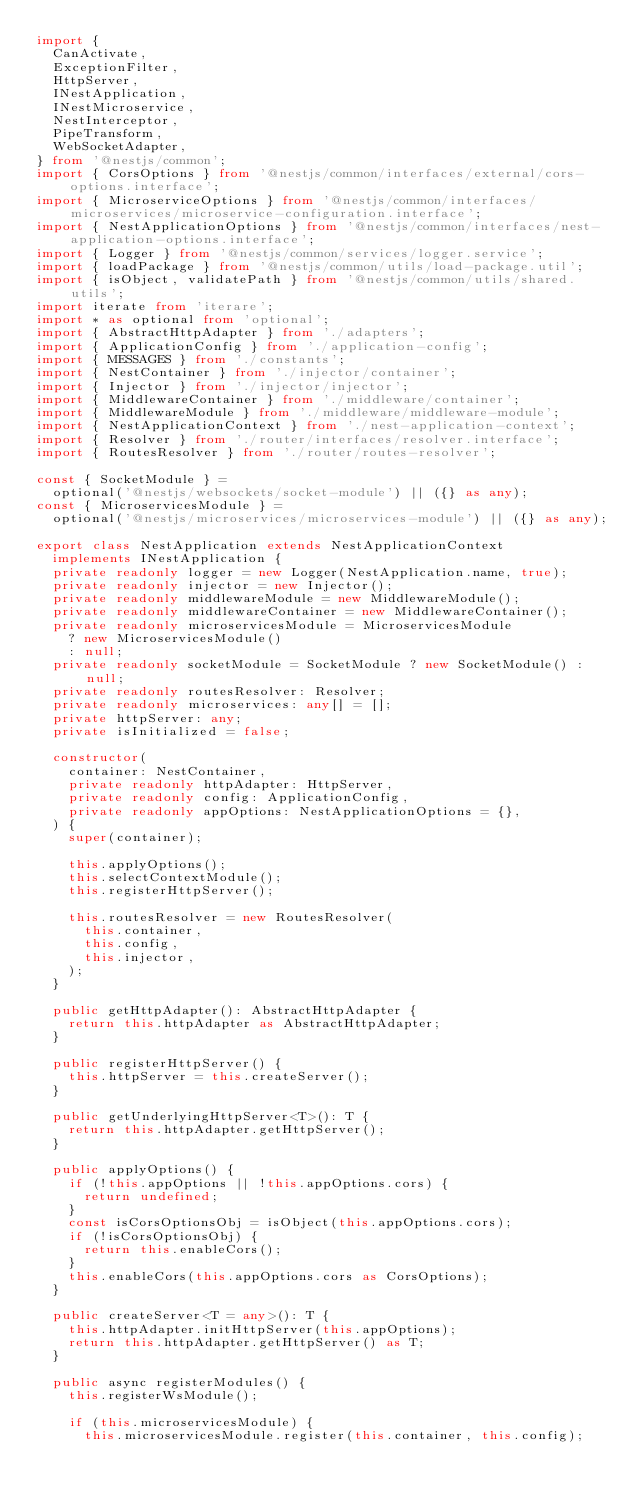Convert code to text. <code><loc_0><loc_0><loc_500><loc_500><_TypeScript_>import {
  CanActivate,
  ExceptionFilter,
  HttpServer,
  INestApplication,
  INestMicroservice,
  NestInterceptor,
  PipeTransform,
  WebSocketAdapter,
} from '@nestjs/common';
import { CorsOptions } from '@nestjs/common/interfaces/external/cors-options.interface';
import { MicroserviceOptions } from '@nestjs/common/interfaces/microservices/microservice-configuration.interface';
import { NestApplicationOptions } from '@nestjs/common/interfaces/nest-application-options.interface';
import { Logger } from '@nestjs/common/services/logger.service';
import { loadPackage } from '@nestjs/common/utils/load-package.util';
import { isObject, validatePath } from '@nestjs/common/utils/shared.utils';
import iterate from 'iterare';
import * as optional from 'optional';
import { AbstractHttpAdapter } from './adapters';
import { ApplicationConfig } from './application-config';
import { MESSAGES } from './constants';
import { NestContainer } from './injector/container';
import { Injector } from './injector/injector';
import { MiddlewareContainer } from './middleware/container';
import { MiddlewareModule } from './middleware/middleware-module';
import { NestApplicationContext } from './nest-application-context';
import { Resolver } from './router/interfaces/resolver.interface';
import { RoutesResolver } from './router/routes-resolver';

const { SocketModule } =
  optional('@nestjs/websockets/socket-module') || ({} as any);
const { MicroservicesModule } =
  optional('@nestjs/microservices/microservices-module') || ({} as any);

export class NestApplication extends NestApplicationContext
  implements INestApplication {
  private readonly logger = new Logger(NestApplication.name, true);
  private readonly injector = new Injector();
  private readonly middlewareModule = new MiddlewareModule();
  private readonly middlewareContainer = new MiddlewareContainer();
  private readonly microservicesModule = MicroservicesModule
    ? new MicroservicesModule()
    : null;
  private readonly socketModule = SocketModule ? new SocketModule() : null;
  private readonly routesResolver: Resolver;
  private readonly microservices: any[] = [];
  private httpServer: any;
  private isInitialized = false;

  constructor(
    container: NestContainer,
    private readonly httpAdapter: HttpServer,
    private readonly config: ApplicationConfig,
    private readonly appOptions: NestApplicationOptions = {},
  ) {
    super(container);

    this.applyOptions();
    this.selectContextModule();
    this.registerHttpServer();

    this.routesResolver = new RoutesResolver(
      this.container,
      this.config,
      this.injector,
    );
  }

  public getHttpAdapter(): AbstractHttpAdapter {
    return this.httpAdapter as AbstractHttpAdapter;
  }

  public registerHttpServer() {
    this.httpServer = this.createServer();
  }

  public getUnderlyingHttpServer<T>(): T {
    return this.httpAdapter.getHttpServer();
  }

  public applyOptions() {
    if (!this.appOptions || !this.appOptions.cors) {
      return undefined;
    }
    const isCorsOptionsObj = isObject(this.appOptions.cors);
    if (!isCorsOptionsObj) {
      return this.enableCors();
    }
    this.enableCors(this.appOptions.cors as CorsOptions);
  }

  public createServer<T = any>(): T {
    this.httpAdapter.initHttpServer(this.appOptions);
    return this.httpAdapter.getHttpServer() as T;
  }

  public async registerModules() {
    this.registerWsModule();

    if (this.microservicesModule) {
      this.microservicesModule.register(this.container, this.config);</code> 